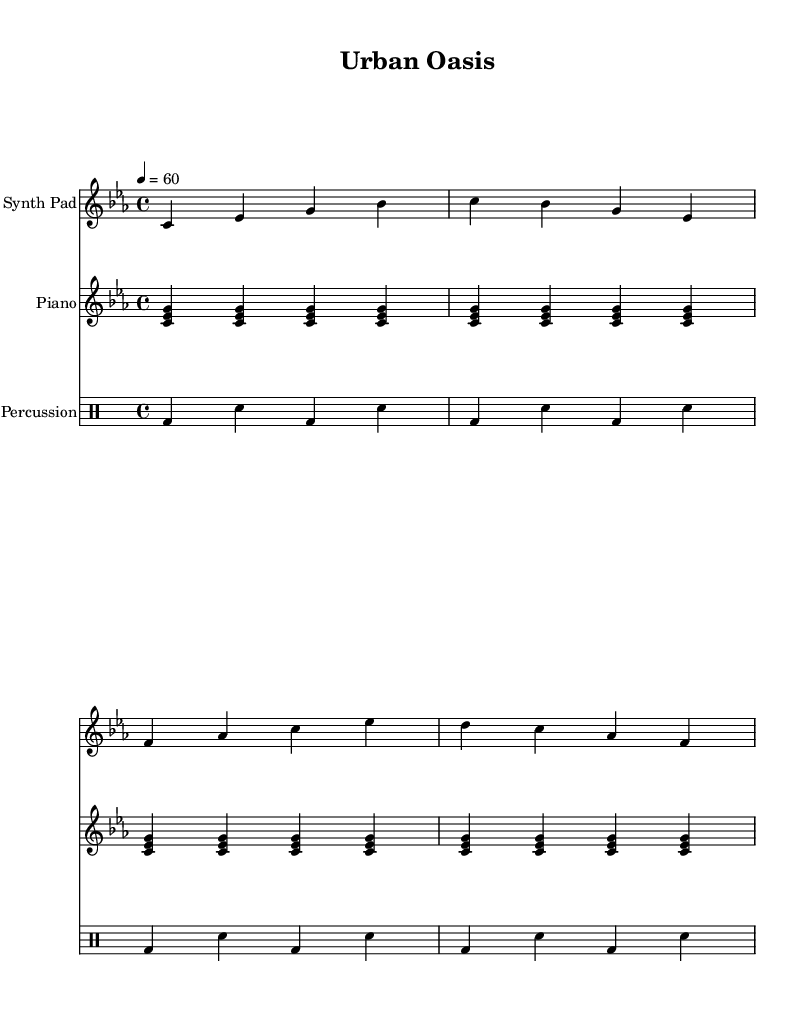What is the key signature of this music? The key signature is C minor, which has three flats (B♭, E♭, and A♭). This is indicated at the beginning of the staff.
Answer: C minor What is the time signature of this music? The time signature is 4/4, which means there are four beats in each measure, and each beat is a quarter note. This is shown at the beginning of the piece.
Answer: 4/4 What is the tempo marking for this piece? The tempo marking is 60 beats per minute, which indicates the speed of the music. This is notated at the beginning of the score.
Answer: 60 How many measures are in the synth pad part? The synth pad part contains a total of four measures, as indicated by the repeated section without any additional notation.
Answer: 4 What type of instruments are used in this piece? The instruments include Synth Pad, Piano, and Percussion, as labeled at the beginning of each staff. This indicates different voices contributing to the overall soundscape.
Answer: Synth Pad, Piano, Percussion Which musical technique is primarily used in the piano part? The technique primarily used in the piano part is a repeated chord pattern, specifically playing a set of three notes (c, es, g) repeatedly over four measures. This creates a consistent harmonic foundation.
Answer: Repeated chords How does the percussion part contribute to the overall ambiance of the piece? The percussion part features a simple pattern with bass and snare drums, creating a subtle rhythmic foundation that supports the dreamy textures of the synth pad and piano. This enhances the ambient feeling of the piece.
Answer: Subtle rhythm 